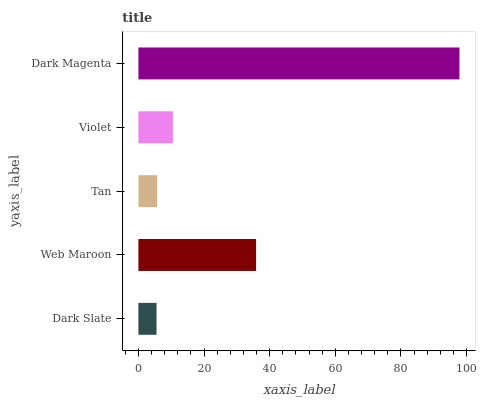Is Dark Slate the minimum?
Answer yes or no. Yes. Is Dark Magenta the maximum?
Answer yes or no. Yes. Is Web Maroon the minimum?
Answer yes or no. No. Is Web Maroon the maximum?
Answer yes or no. No. Is Web Maroon greater than Dark Slate?
Answer yes or no. Yes. Is Dark Slate less than Web Maroon?
Answer yes or no. Yes. Is Dark Slate greater than Web Maroon?
Answer yes or no. No. Is Web Maroon less than Dark Slate?
Answer yes or no. No. Is Violet the high median?
Answer yes or no. Yes. Is Violet the low median?
Answer yes or no. Yes. Is Web Maroon the high median?
Answer yes or no. No. Is Tan the low median?
Answer yes or no. No. 